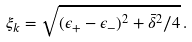<formula> <loc_0><loc_0><loc_500><loc_500>\xi _ { k } = \sqrt { ( \epsilon _ { + } - \epsilon _ { - } ) ^ { 2 } + { \bar { \delta } } ^ { 2 } / 4 } \, .</formula> 